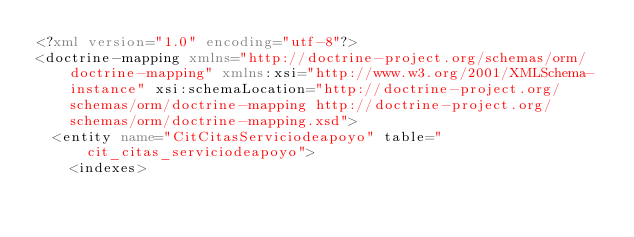<code> <loc_0><loc_0><loc_500><loc_500><_XML_><?xml version="1.0" encoding="utf-8"?>
<doctrine-mapping xmlns="http://doctrine-project.org/schemas/orm/doctrine-mapping" xmlns:xsi="http://www.w3.org/2001/XMLSchema-instance" xsi:schemaLocation="http://doctrine-project.org/schemas/orm/doctrine-mapping http://doctrine-project.org/schemas/orm/doctrine-mapping.xsd">
  <entity name="CitCitasServiciodeapoyo" table="cit_citas_serviciodeapoyo">
    <indexes></code> 